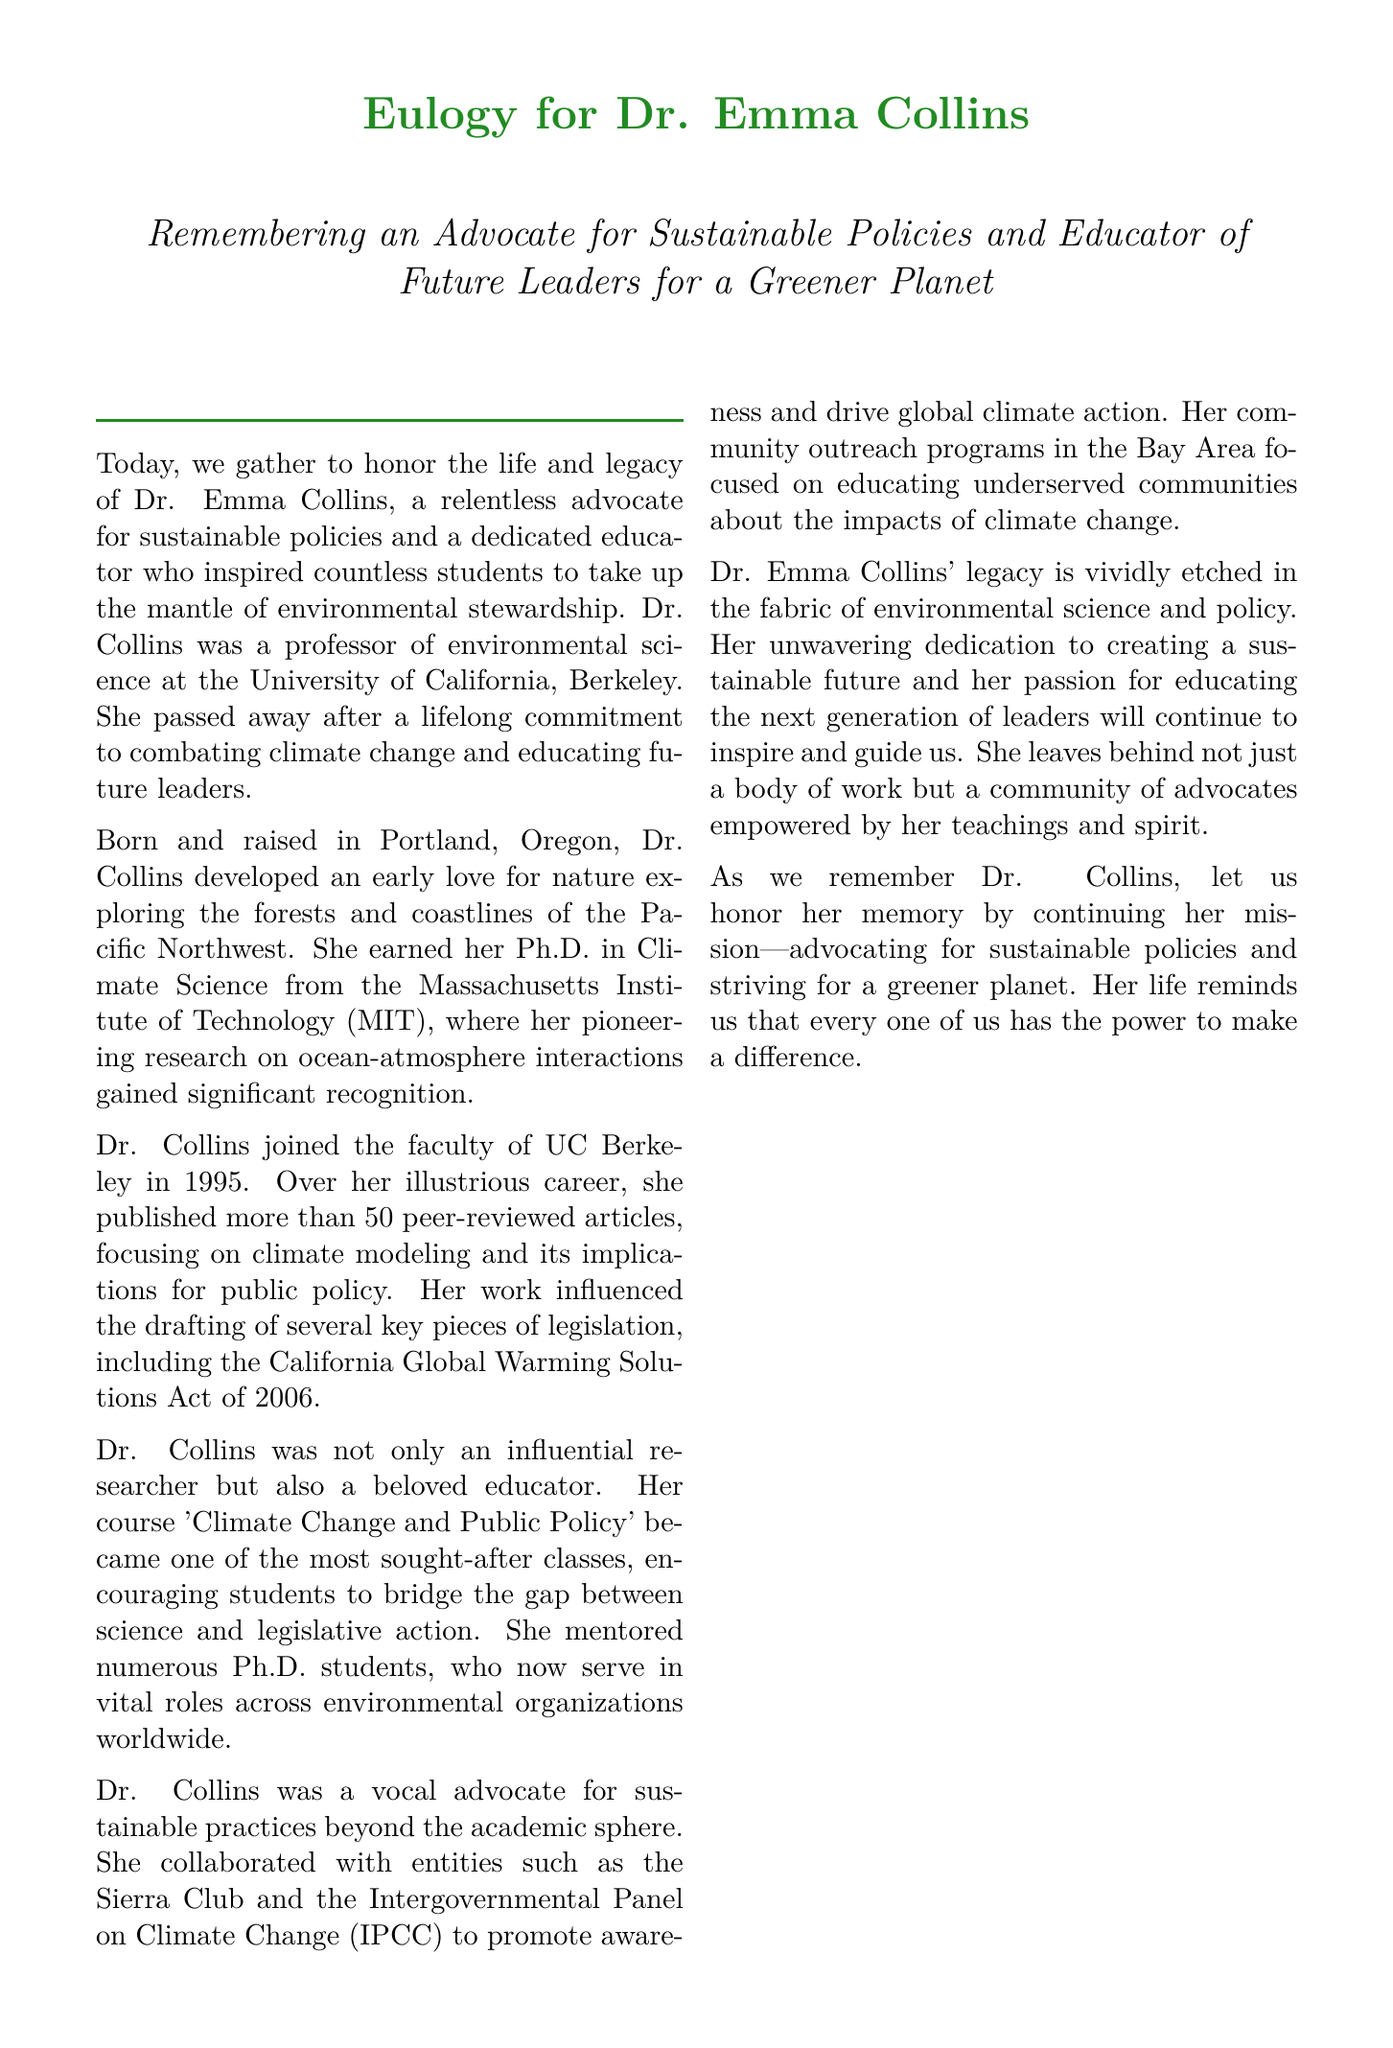What was Dr. Collins' position? Dr. Collins was a professor at UC Berkeley, which is stated in the document.
Answer: professor of environmental science What year did Dr. Collins join UC Berkeley? The document mentions that Dr. Collins joined UC Berkeley in 1995.
Answer: 1995 How many peer-reviewed articles did Dr. Collins publish? The eulogy states that she published more than 50 peer-reviewed articles.
Answer: more than 50 What was the name of Dr. Collins' course? The course that Dr. Collins taught is mentioned as 'Climate Change and Public Policy'.
Answer: Climate Change and Public Policy What organizations did Dr. Collins collaborate with? The document lists the Sierra Club and the IPCC as organizations she worked with.
Answer: Sierra Club and IPCC What significant legislation influenced by Dr. Collins was mentioned? The California Global Warming Solutions Act of 2006 is cited in the eulogy.
Answer: California Global Warming Solutions Act of 2006 What did Dr. Collins focus on in her community outreach programs? The eulogy highlights that her outreach programs focused on educating underserved communities about climate change.
Answer: educating underserved communities What qualities characterized Dr. Collins' teaching? The document describes her teaching as inspiring and her course sought-after, emphasizing her impact as an educator.
Answer: inspiring, sought-after What is one of the quotes included in the eulogy? The document includes a quote by Baba Dioum about conservation and understanding.
Answer: "In the end we will conserve only what we love; we will love only what we understand; and we will understand only what we are taught." 